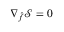Convert formula to latex. <formula><loc_0><loc_0><loc_500><loc_500>\nabla _ { \hat { f } } \mathcal { S } = 0</formula> 